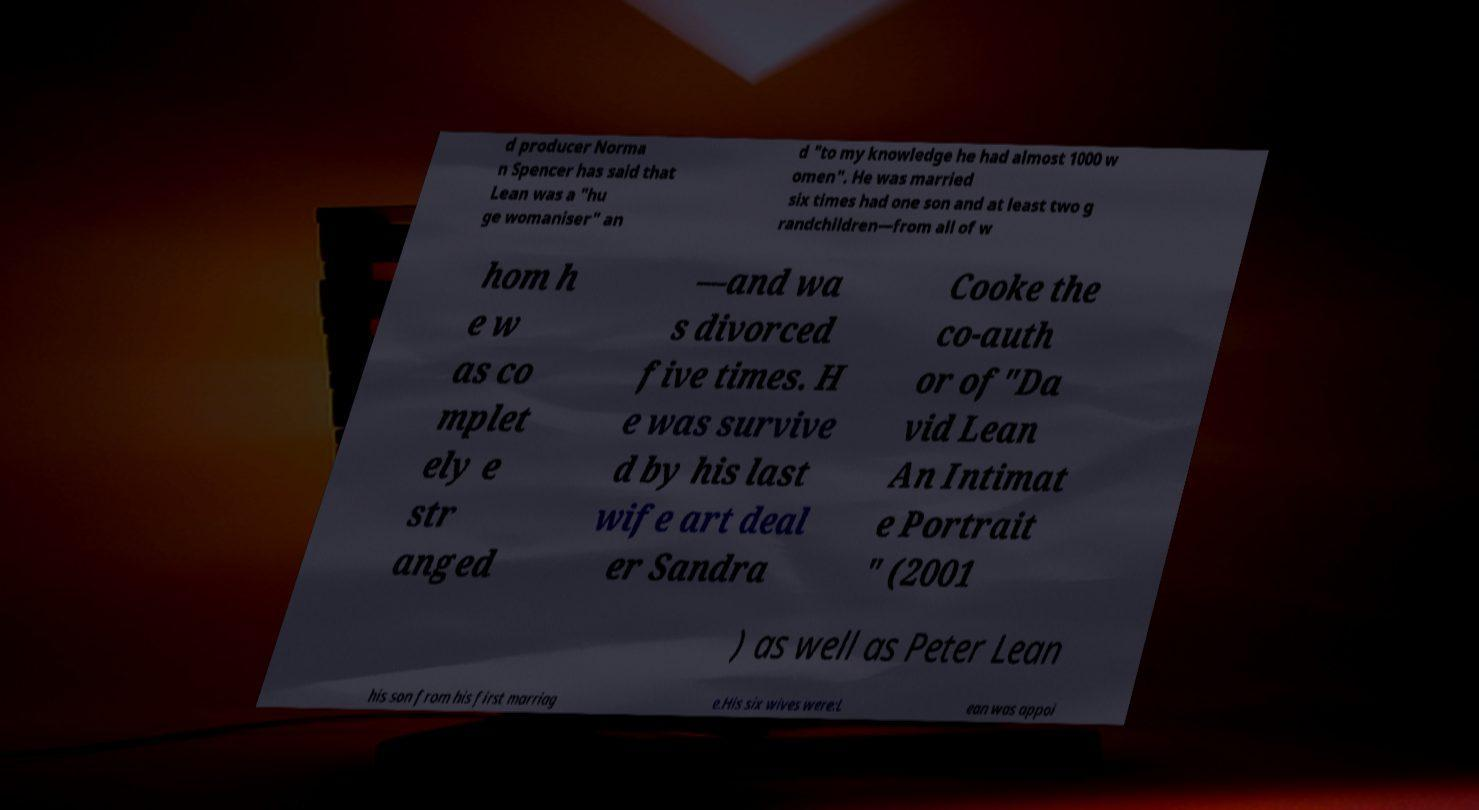There's text embedded in this image that I need extracted. Can you transcribe it verbatim? d producer Norma n Spencer has said that Lean was a "hu ge womaniser" an d "to my knowledge he had almost 1000 w omen". He was married six times had one son and at least two g randchildren—from all of w hom h e w as co mplet ely e str anged —and wa s divorced five times. H e was survive d by his last wife art deal er Sandra Cooke the co-auth or of"Da vid Lean An Intimat e Portrait " (2001 ) as well as Peter Lean his son from his first marriag e.His six wives were:L ean was appoi 